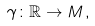<formula> <loc_0><loc_0><loc_500><loc_500>\gamma \colon \mathbb { R } \rightarrow M \, ,</formula> 